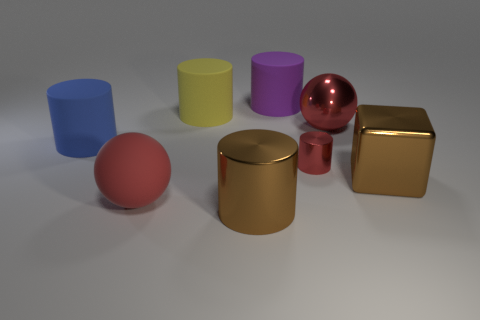Subtract 2 cylinders. How many cylinders are left? 3 Subtract all small cylinders. How many cylinders are left? 4 Subtract all brown cylinders. How many cylinders are left? 4 Add 2 big red rubber balls. How many objects exist? 10 Subtract all gray cylinders. Subtract all blue cubes. How many cylinders are left? 5 Subtract all balls. How many objects are left? 6 Add 1 big red spheres. How many big red spheres exist? 3 Subtract 2 red spheres. How many objects are left? 6 Subtract all blue matte cylinders. Subtract all big yellow matte cylinders. How many objects are left? 6 Add 8 yellow matte cylinders. How many yellow matte cylinders are left? 9 